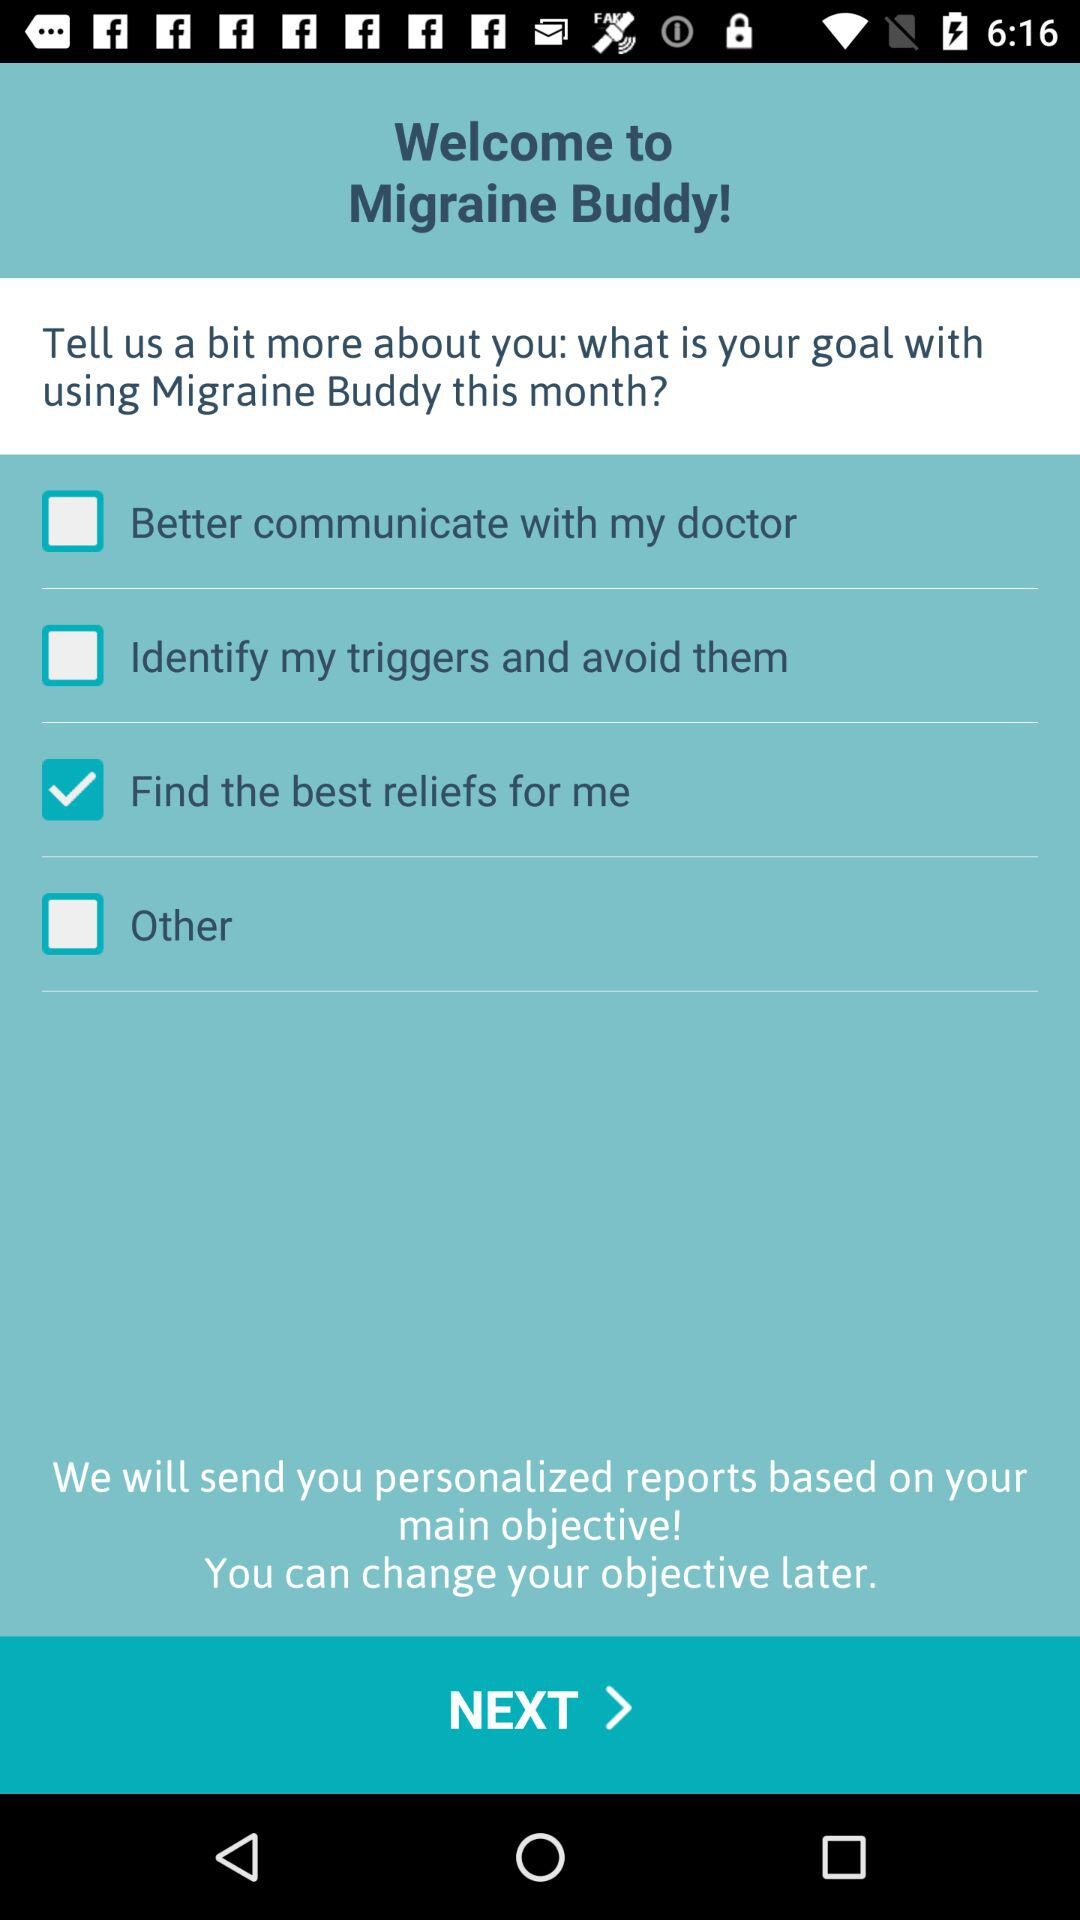What is the application name? The application name is "Migraine Buddy". 